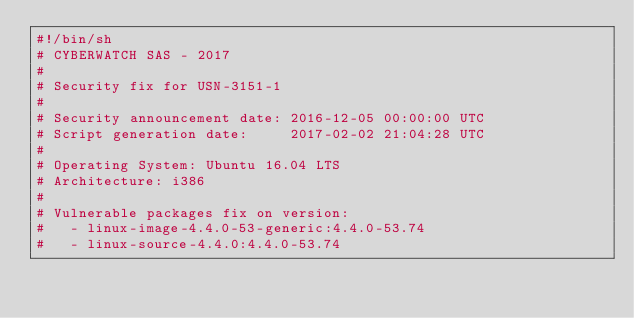<code> <loc_0><loc_0><loc_500><loc_500><_Bash_>#!/bin/sh
# CYBERWATCH SAS - 2017
#
# Security fix for USN-3151-1
#
# Security announcement date: 2016-12-05 00:00:00 UTC
# Script generation date:     2017-02-02 21:04:28 UTC
#
# Operating System: Ubuntu 16.04 LTS
# Architecture: i386
#
# Vulnerable packages fix on version:
#   - linux-image-4.4.0-53-generic:4.4.0-53.74
#   - linux-source-4.4.0:4.4.0-53.74</code> 